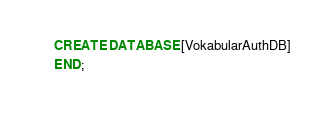<code> <loc_0><loc_0><loc_500><loc_500><_SQL_>CREATE DATABASE [VokabularAuthDB]
END;</code> 